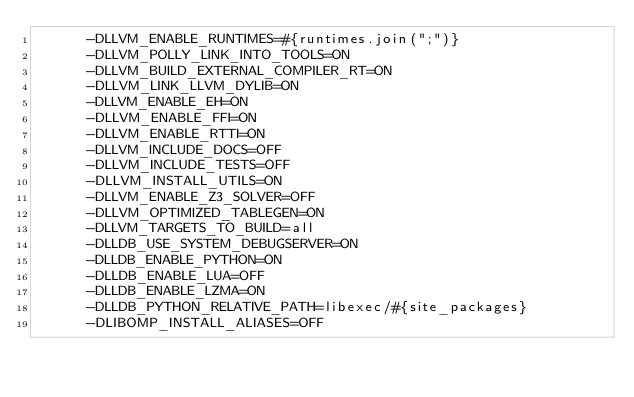Convert code to text. <code><loc_0><loc_0><loc_500><loc_500><_Ruby_>      -DLLVM_ENABLE_RUNTIMES=#{runtimes.join(";")}
      -DLLVM_POLLY_LINK_INTO_TOOLS=ON
      -DLLVM_BUILD_EXTERNAL_COMPILER_RT=ON
      -DLLVM_LINK_LLVM_DYLIB=ON
      -DLLVM_ENABLE_EH=ON
      -DLLVM_ENABLE_FFI=ON
      -DLLVM_ENABLE_RTTI=ON
      -DLLVM_INCLUDE_DOCS=OFF
      -DLLVM_INCLUDE_TESTS=OFF
      -DLLVM_INSTALL_UTILS=ON
      -DLLVM_ENABLE_Z3_SOLVER=OFF
      -DLLVM_OPTIMIZED_TABLEGEN=ON
      -DLLVM_TARGETS_TO_BUILD=all
      -DLLDB_USE_SYSTEM_DEBUGSERVER=ON
      -DLLDB_ENABLE_PYTHON=ON
      -DLLDB_ENABLE_LUA=OFF
      -DLLDB_ENABLE_LZMA=ON
      -DLLDB_PYTHON_RELATIVE_PATH=libexec/#{site_packages}
      -DLIBOMP_INSTALL_ALIASES=OFF</code> 